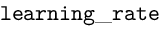<formula> <loc_0><loc_0><loc_500><loc_500>l e a r n i n g \_ r a t e</formula> 